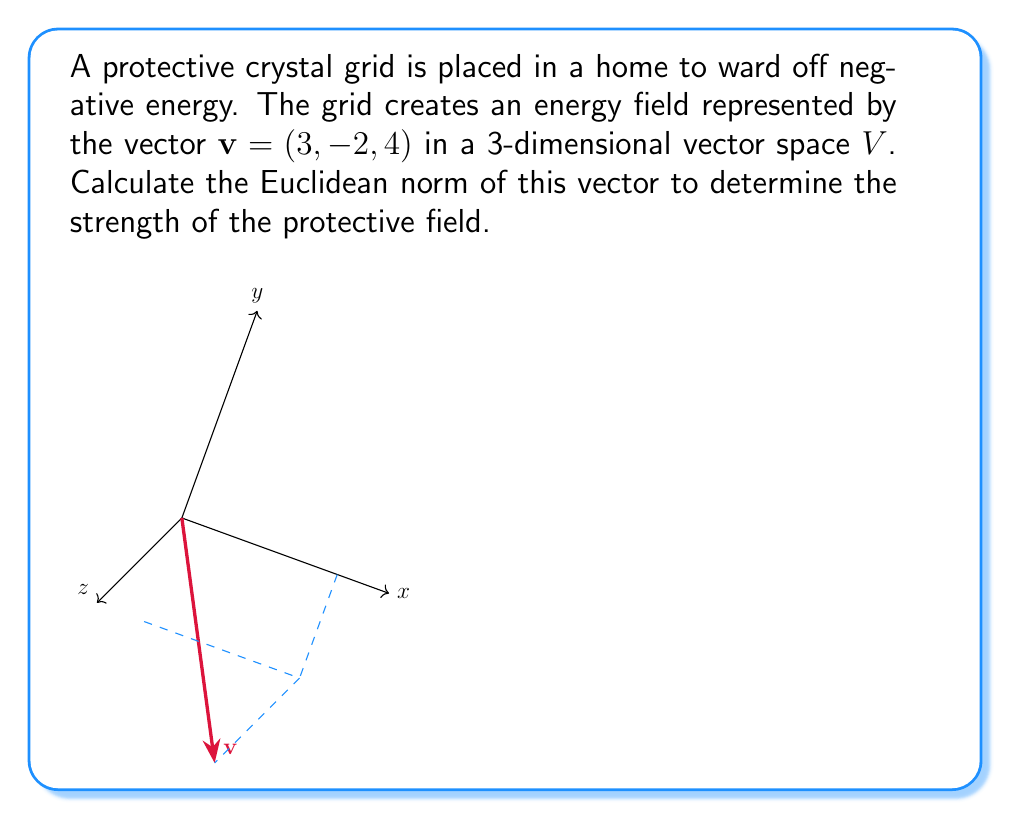Can you solve this math problem? To calculate the Euclidean norm of the vector $v = (3, -2, 4)$, we follow these steps:

1) The Euclidean norm (also known as L2 norm) of a vector $v = (x_1, x_2, ..., x_n)$ in an n-dimensional vector space is defined as:

   $$\|v\| = \sqrt{\sum_{i=1}^n |x_i|^2}$$

2) For our 3-dimensional vector $v = (3, -2, 4)$, we have:

   $$\|v\| = \sqrt{|3|^2 + |-2|^2 + |4|^2}$$

3) Simplify the expression under the square root:

   $$\|v\| = \sqrt{9 + 4 + 16}$$

4) Add the terms under the square root:

   $$\|v\| = \sqrt{29}$$

5) This is our final answer, as $\sqrt{29}$ cannot be simplified further.

The Euclidean norm represents the length of the vector in the vector space, which in this context can be interpreted as the strength of the protective energy field.
Answer: $\sqrt{29}$ 